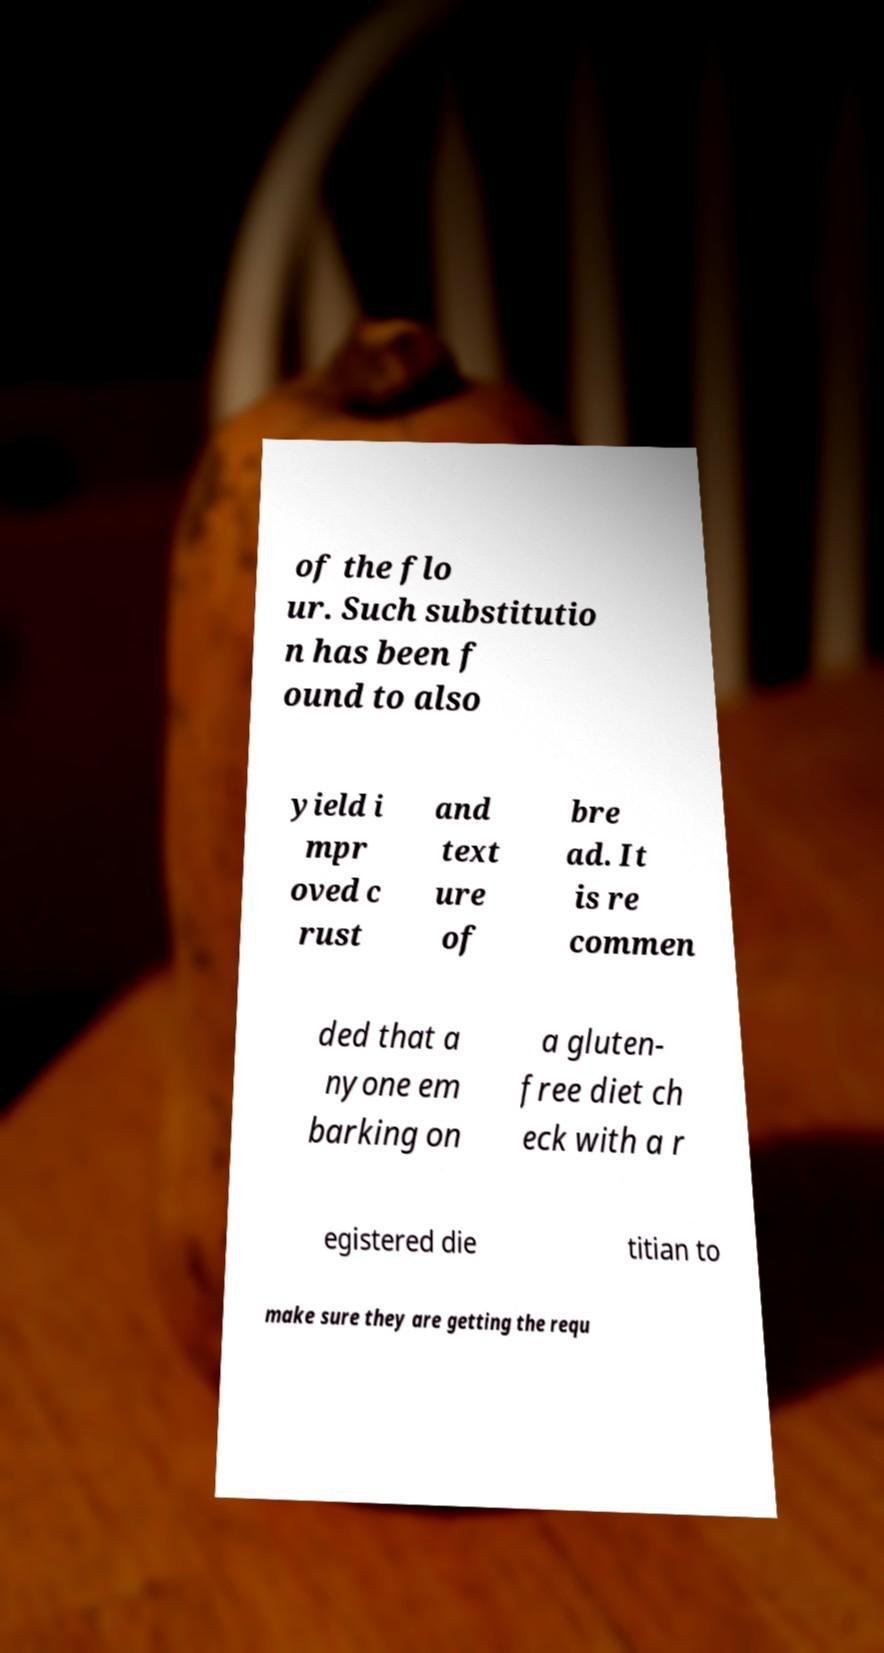Please read and relay the text visible in this image. What does it say? of the flo ur. Such substitutio n has been f ound to also yield i mpr oved c rust and text ure of bre ad. It is re commen ded that a nyone em barking on a gluten- free diet ch eck with a r egistered die titian to make sure they are getting the requ 